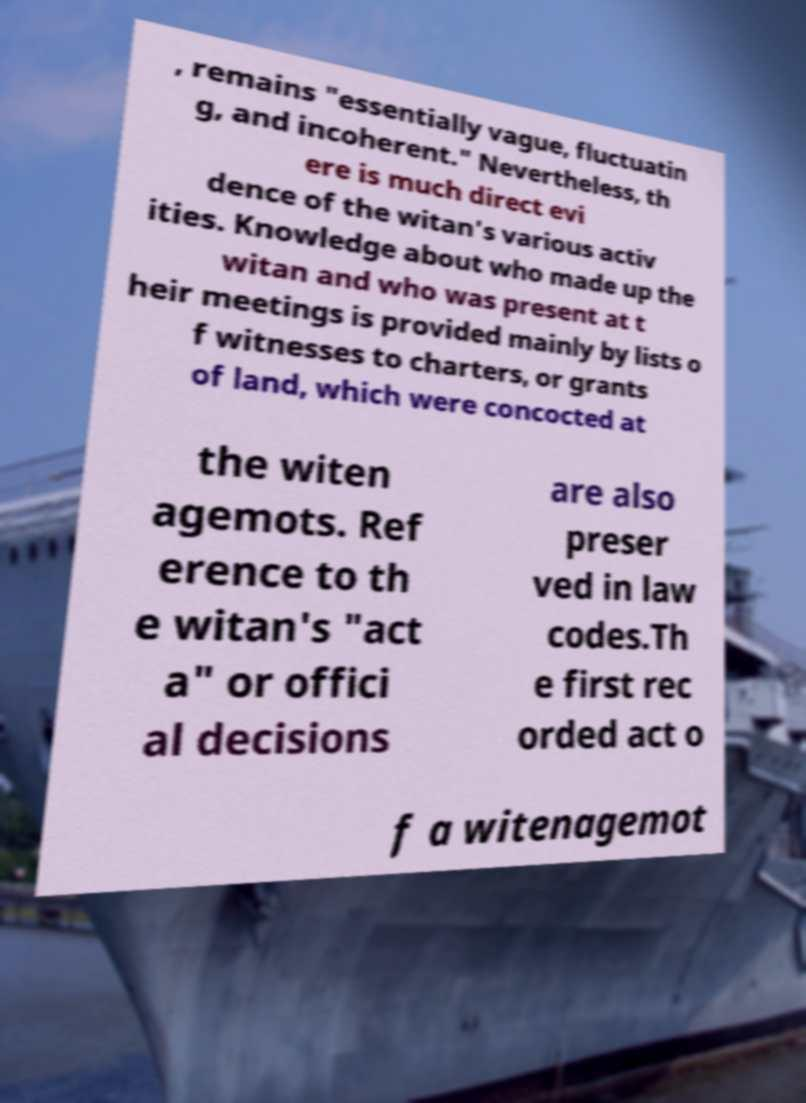Please identify and transcribe the text found in this image. , remains "essentially vague, fluctuatin g, and incoherent." Nevertheless, th ere is much direct evi dence of the witan's various activ ities. Knowledge about who made up the witan and who was present at t heir meetings is provided mainly by lists o f witnesses to charters, or grants of land, which were concocted at the witen agemots. Ref erence to th e witan's "act a" or offici al decisions are also preser ved in law codes.Th e first rec orded act o f a witenagemot 